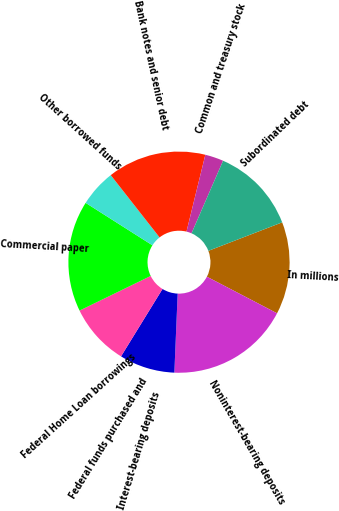Convert chart to OTSL. <chart><loc_0><loc_0><loc_500><loc_500><pie_chart><fcel>In millions<fcel>Noninterest-bearing deposits<fcel>Interest-bearing deposits<fcel>Federal funds purchased and<fcel>Federal Home Loan borrowings<fcel>Commercial paper<fcel>Other borrowed funds<fcel>Bank notes and senior debt<fcel>Common and treasury stock<fcel>Subordinated debt<nl><fcel>13.51%<fcel>18.02%<fcel>8.11%<fcel>0.0%<fcel>9.01%<fcel>16.22%<fcel>5.41%<fcel>14.41%<fcel>2.7%<fcel>12.61%<nl></chart> 